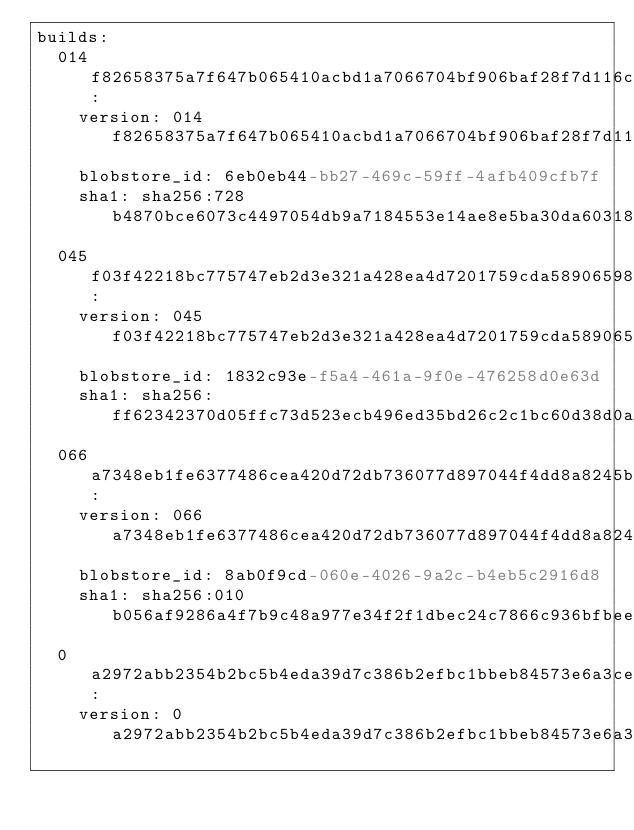Convert code to text. <code><loc_0><loc_0><loc_500><loc_500><_YAML_>builds:
  014f82658375a7f647b065410acbd1a7066704bf906baf28f7d116c0e6f3cd2d:
    version: 014f82658375a7f647b065410acbd1a7066704bf906baf28f7d116c0e6f3cd2d
    blobstore_id: 6eb0eb44-bb27-469c-59ff-4afb409cfb7f
    sha1: sha256:728b4870bce6073c4497054db9a7184553e14ae8e5ba30da60318e89577a94ef
  045f03f42218bc775747eb2d3e321a428ea4d7201759cda5890659808a7c347a:
    version: 045f03f42218bc775747eb2d3e321a428ea4d7201759cda5890659808a7c347a
    blobstore_id: 1832c93e-f5a4-461a-9f0e-476258d0e63d
    sha1: sha256:ff62342370d05ffc73d523ecb496ed35bd26c2c1bc60d38d0a84bd9917258305
  066a7348eb1fe6377486cea420d72db736077d897044f4dd8a8245b8a9b31b81:
    version: 066a7348eb1fe6377486cea420d72db736077d897044f4dd8a8245b8a9b31b81
    blobstore_id: 8ab0f9cd-060e-4026-9a2c-b4eb5c2916d8
    sha1: sha256:010b056af9286a4f7b9c48a977e34f2f1dbec24c7866c936bfbee12546b8ce68
  0a2972abb2354b2bc5b4eda39d7c386b2efbc1bbeb84573e6a3ce4824f966141:
    version: 0a2972abb2354b2bc5b4eda39d7c386b2efbc1bbeb84573e6a3ce4824f966141</code> 